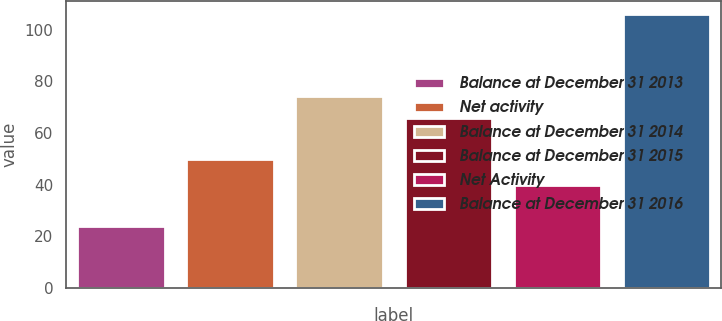<chart> <loc_0><loc_0><loc_500><loc_500><bar_chart><fcel>Balance at December 31 2013<fcel>Net activity<fcel>Balance at December 31 2014<fcel>Balance at December 31 2015<fcel>Net Activity<fcel>Balance at December 31 2016<nl><fcel>24<fcel>50<fcel>74.2<fcel>66<fcel>40<fcel>106<nl></chart> 